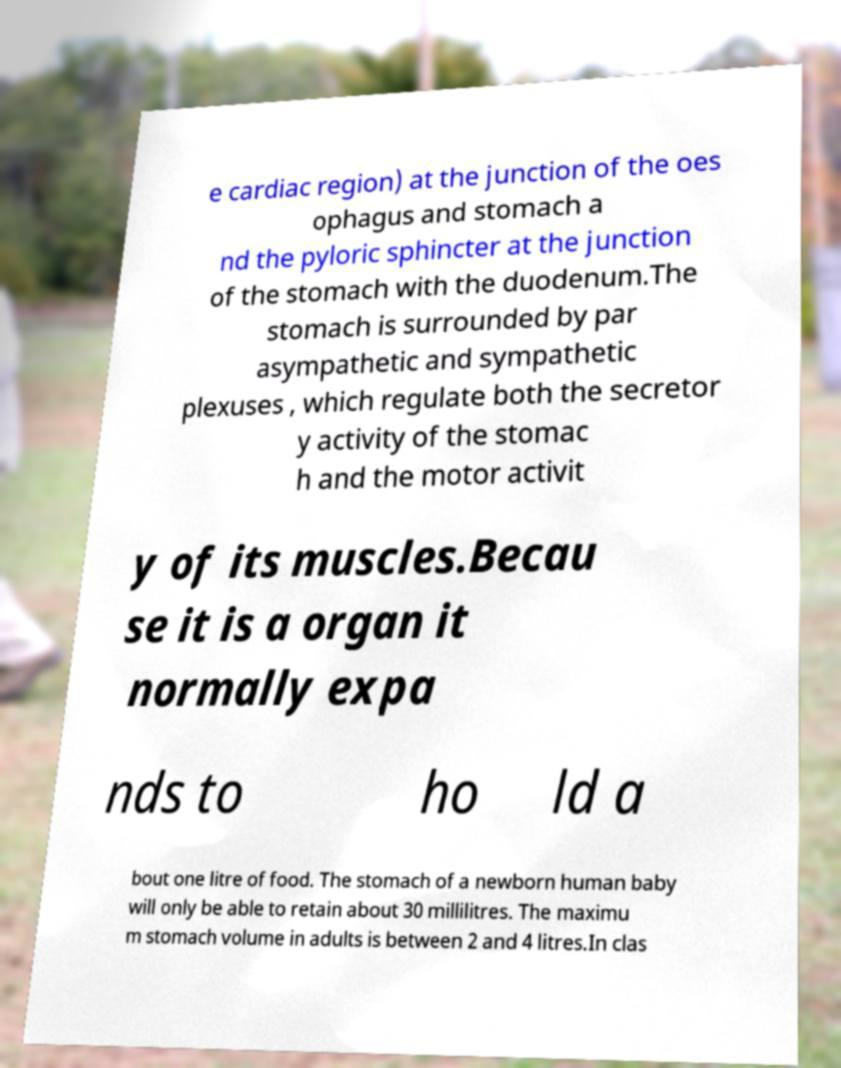Can you read and provide the text displayed in the image?This photo seems to have some interesting text. Can you extract and type it out for me? e cardiac region) at the junction of the oes ophagus and stomach a nd the pyloric sphincter at the junction of the stomach with the duodenum.The stomach is surrounded by par asympathetic and sympathetic plexuses , which regulate both the secretor y activity of the stomac h and the motor activit y of its muscles.Becau se it is a organ it normally expa nds to ho ld a bout one litre of food. The stomach of a newborn human baby will only be able to retain about 30 millilitres. The maximu m stomach volume in adults is between 2 and 4 litres.In clas 